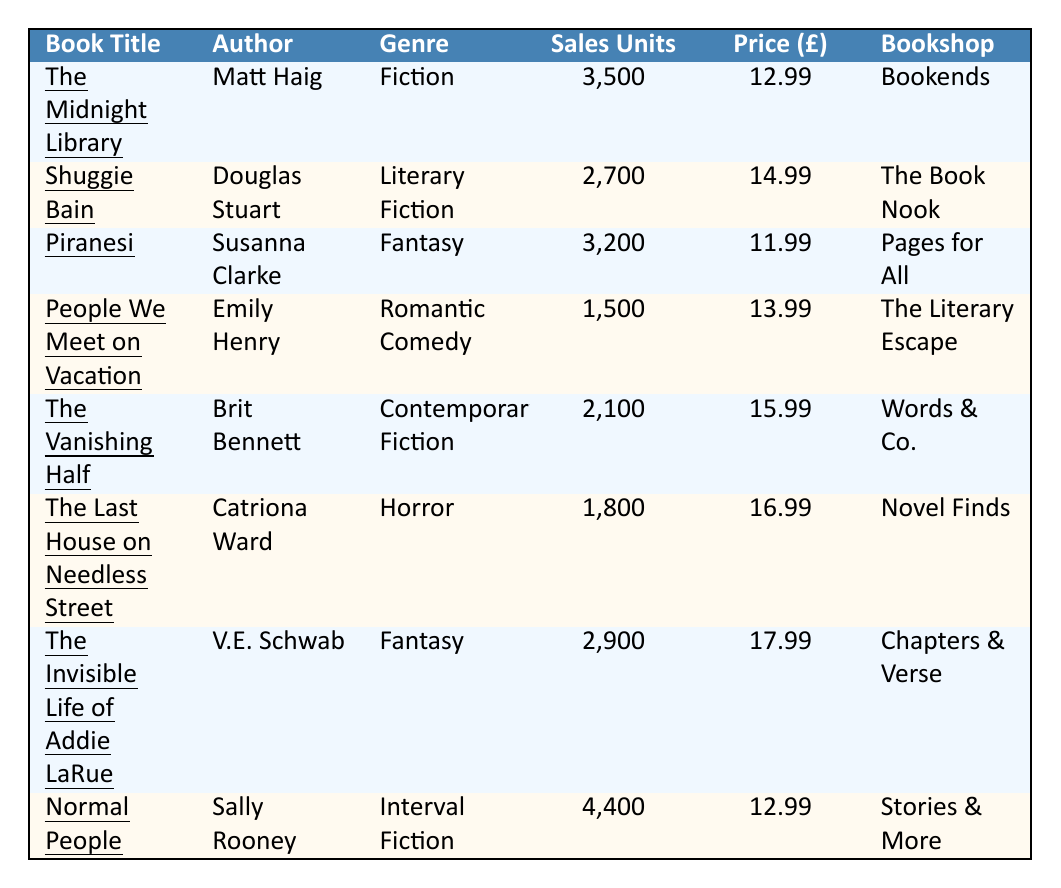What is the highest sales unit figure in the table? Looking through the sales units, "Normal People" has the highest figure at 4,400.
Answer: 4,400 Which bookshop sold "Shuggie Bain"? The table lists "Shuggie Bain" as sold at "The Book Nook".
Answer: The Book Nook What is the price of "The Last House on Needless Street"? The table states that "The Last House on Needless Street" is priced at £16.99.
Answer: £16.99 How many total sales units were recorded for all the books listed in the table? Adding the sales units: 3500 + 2700 + 3200 + 1500 + 2100 + 1800 + 2900 + 4400 = 22,600 units sold.
Answer: 22,600 Is "Piranesi" classified as a Fantasy novel? Yes, according to the genre column, "Piranesi" is categorized under Fantasy.
Answer: Yes What is the average price of all the books listed? Adding the prices gives £12.99 + £14.99 + £11.99 + £13.99 + £15.99 + £16.99 + £17.99 + £12.99 = £116.92. Dividing by the 8 books, the average price is £116.92 / 8 = £14.61.
Answer: £14.61 Which author has the book with the lowest sales? "People We Meet on Vacation" by Emily Henry has the lowest sales at 1,500 units.
Answer: Emily Henry How much more successful was "Normal People" compared to "The Last House on Needless Street" in terms of sales units? "Normal People" sold 4,400 units and "The Last House on Needless Street" sold 1,800 units. The difference is 4,400 - 1,800 = 2,600 units.
Answer: 2,600 What genre is the book with the highest number of sales? "Normal People", which has the highest sales, belongs to the genre of Interval Fiction.
Answer: Interval Fiction Which bookshop had the highest selling book? "Normal People" from "Stories & More" sold the most units, at 4,400.
Answer: Stories & More 